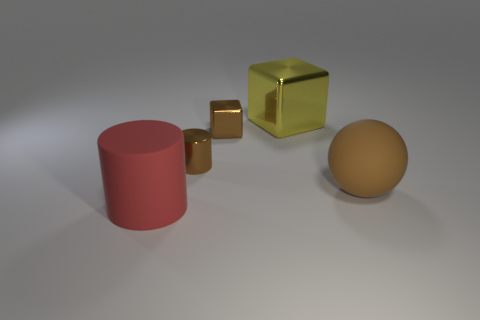Can you describe the colors and shapes present in the image? Certainly! The image features a collection of geometric shapes including a cylinder that is rose-colored, two cubes – one large and yellow with a metallic finish and a smaller one golden and quite reflective, and a matte-finished sphere with a hue that resembles beige or light brown. 